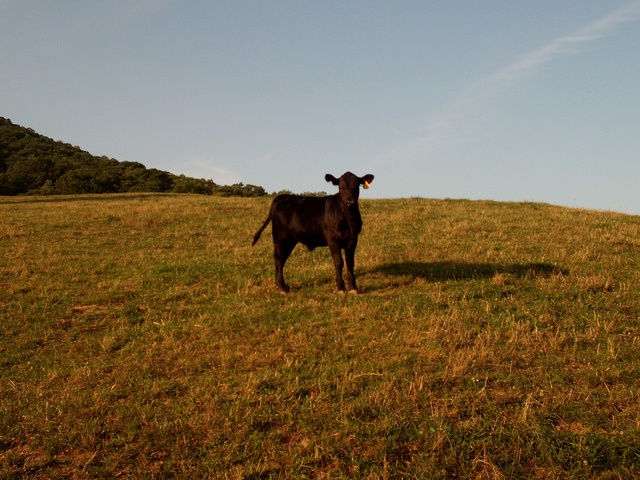Describe the objects in this image and their specific colors. I can see a cow in darkgray, black, maroon, olive, and brown tones in this image. 